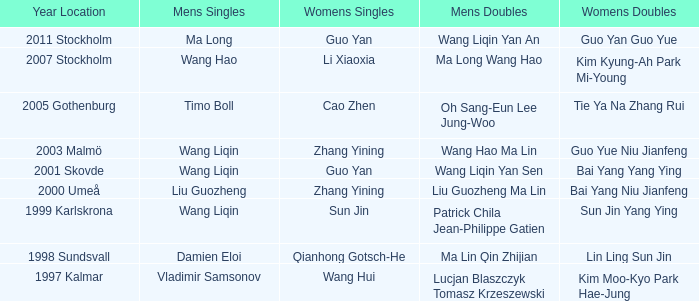How many times has Sun Jin won the women's doubles? 1.0. 